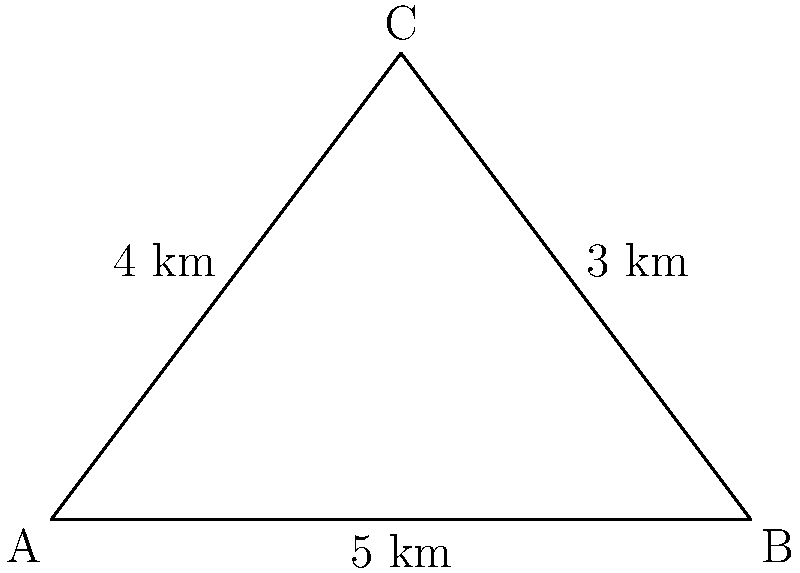An ancient battlefield site near Angkor Wat has been discovered in the shape of a triangle. Archaeologists need to fence off the entire perimeter for preservation. If the sides of the triangular site measure 3 km, 4 km, and 5 km, what is the total length of fencing required to enclose the site? To calculate the perimeter of the triangular battlefield site, we need to sum the lengths of all three sides:

1. Side 1: 3 km
2. Side 2: 4 km
3. Side 3: 5 km

The formula for perimeter is:

$$ P = a + b + c $$

Where $P$ is the perimeter, and $a$, $b$, and $c$ are the lengths of the sides.

Substituting the values:

$$ P = 3 + 4 + 5 $$

$$ P = 12 $$

Therefore, the total length of fencing required to enclose the site is 12 km.
Answer: 12 km 